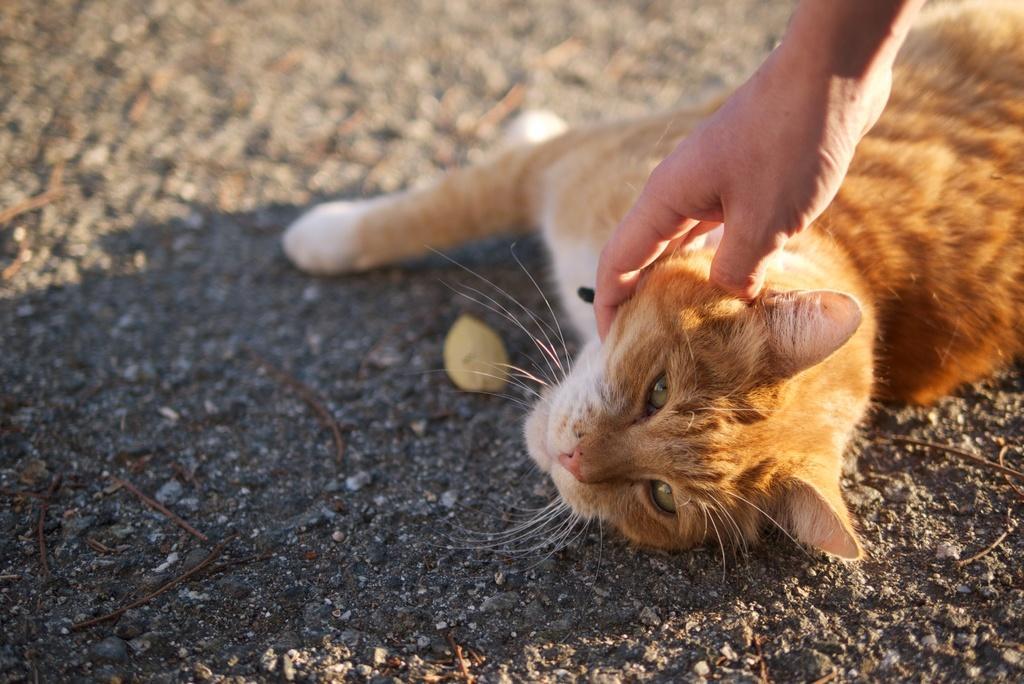Could you give a brief overview of what you see in this image? In this image we can see a cat which is of brown and white color is resting on the ground and we can see a person's hand who is pampering the cat. 